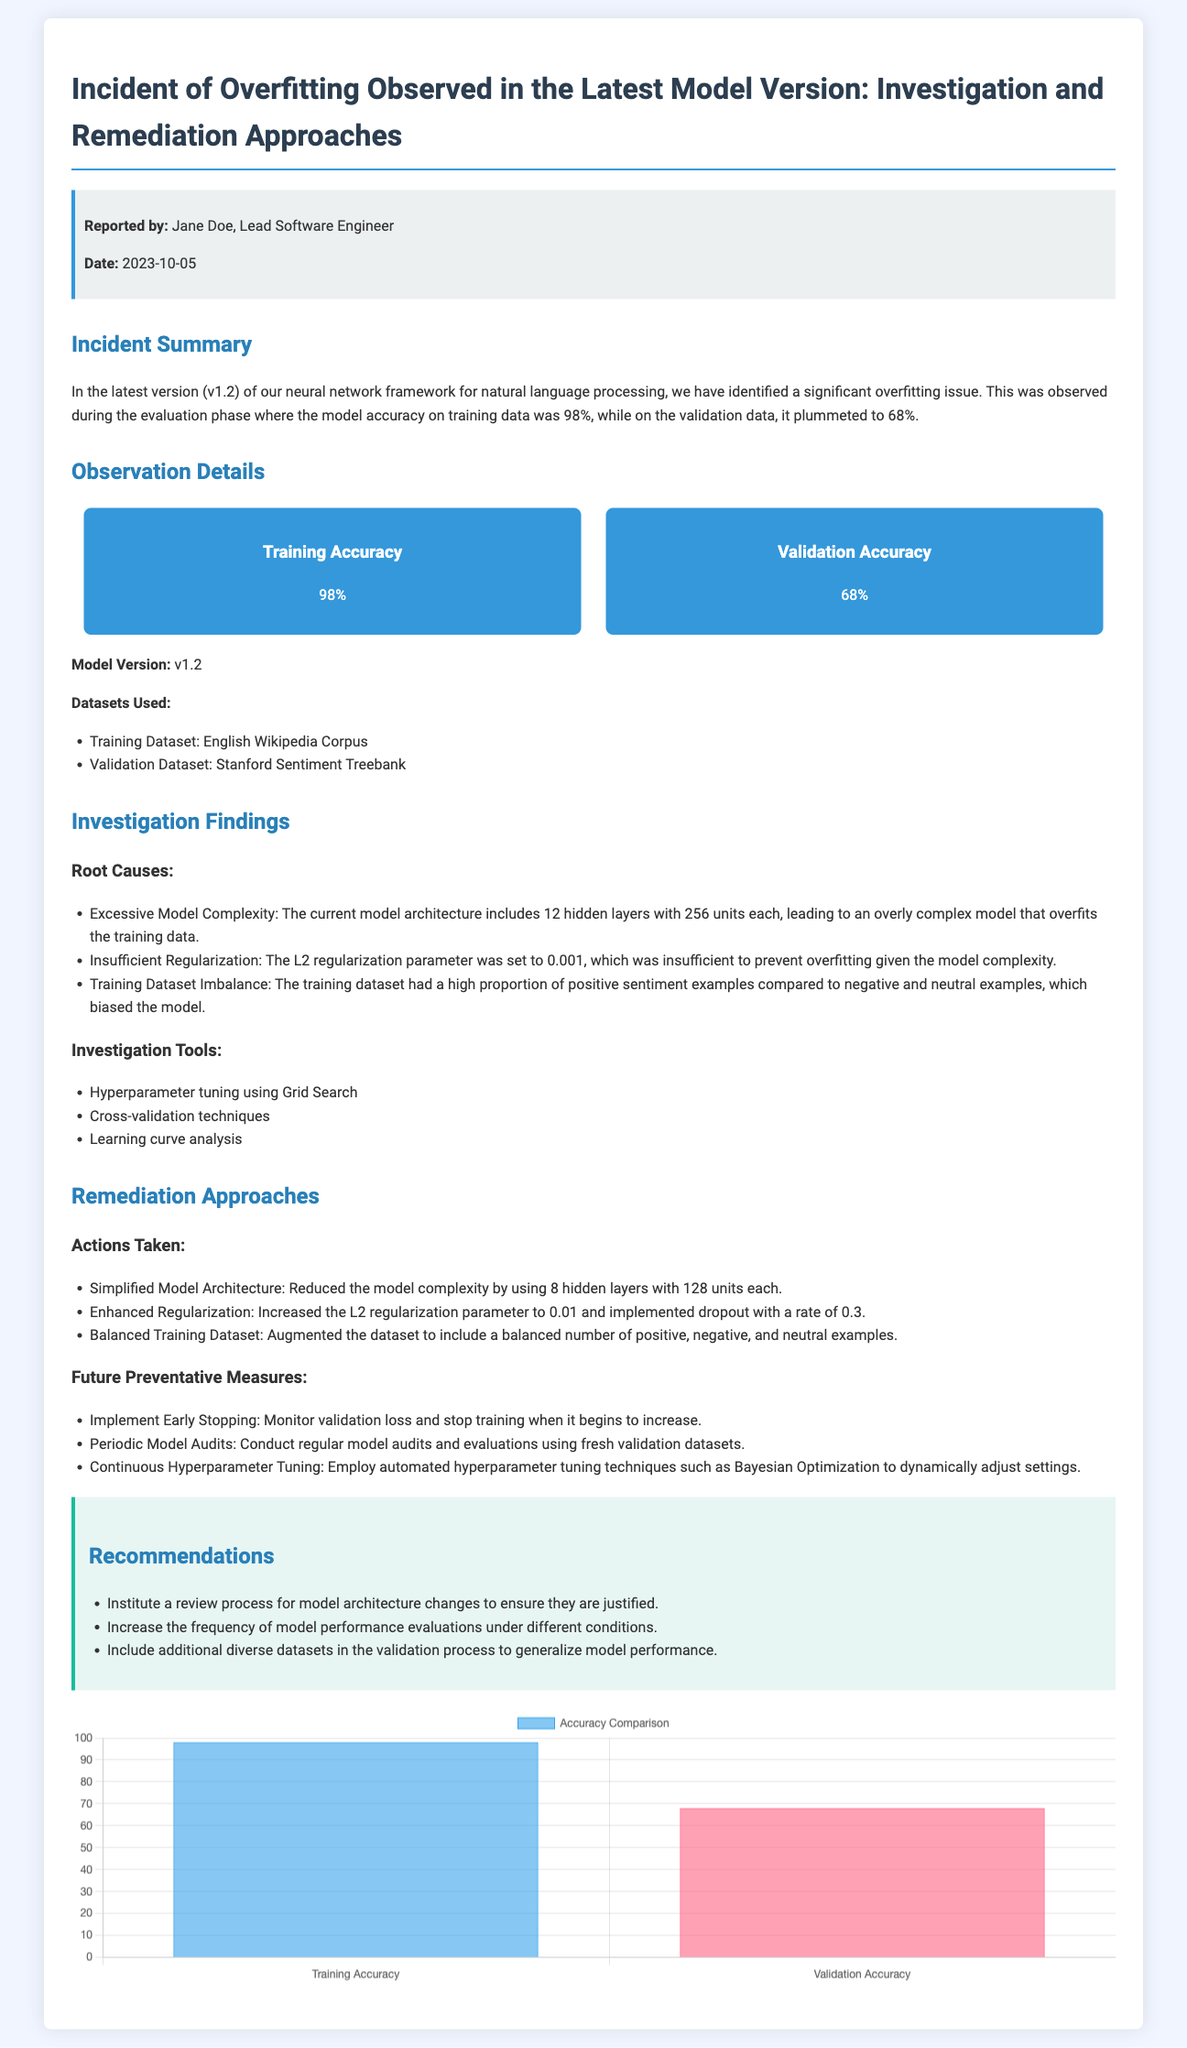what is the model version with overfitting? The document states that the model version experiencing overfitting is v1.2.
Answer: v1.2 who reported the incident? The incident report mentions Jane Doe as the individual who reported it.
Answer: Jane Doe what was the training accuracy percentage? The document specifies that the training accuracy was 98%.
Answer: 98% what was the validation accuracy percentage? According to the report, the validation accuracy was notably lower at 68%.
Answer: 68% how many hidden layers were originally used in the model? The report indicates that the original model architecture included 12 hidden layers.
Answer: 12 what was the L2 regularization parameter before remediation? The document indicates that the L2 regularization parameter was set to 0.001 initially.
Answer: 0.001 what is one tool used during the investigation? The investigation utilized hyperparameter tuning as one of its tools.
Answer: Hyperparameter tuning what is the reduced number of hidden layers in the simplified model architecture? The report states that the model complexity was reduced to 8 hidden layers.
Answer: 8 what is a future preventative measure mentioned in the report? The report includes implementing early stopping as a future preventative measure.
Answer: Implement Early Stopping what is one recommendation provided in the report? The document recommends instituting a review process for model architecture changes.
Answer: Institute a review process 